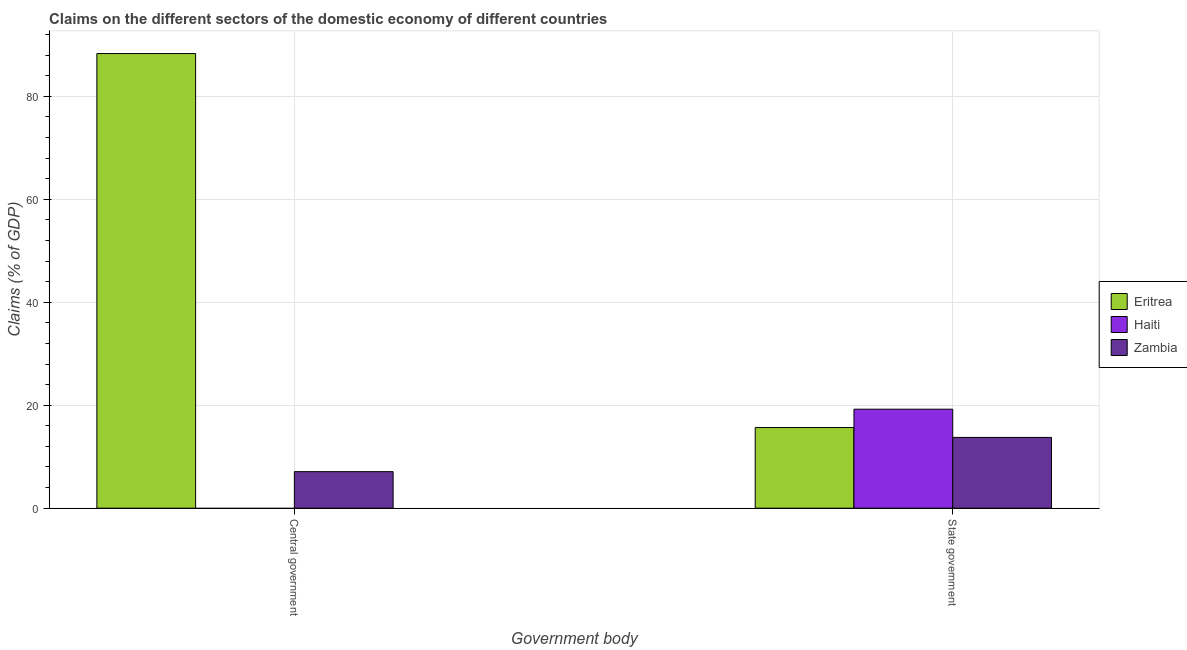Are the number of bars per tick equal to the number of legend labels?
Offer a terse response. No. What is the label of the 1st group of bars from the left?
Make the answer very short. Central government. What is the claims on state government in Zambia?
Ensure brevity in your answer.  13.75. Across all countries, what is the maximum claims on central government?
Keep it short and to the point. 88.29. In which country was the claims on state government maximum?
Offer a terse response. Haiti. What is the total claims on state government in the graph?
Your response must be concise. 48.63. What is the difference between the claims on state government in Eritrea and that in Zambia?
Ensure brevity in your answer.  1.91. What is the difference between the claims on state government in Eritrea and the claims on central government in Zambia?
Keep it short and to the point. 8.56. What is the average claims on state government per country?
Provide a succinct answer. 16.21. What is the difference between the claims on central government and claims on state government in Eritrea?
Your answer should be very brief. 72.63. In how many countries, is the claims on central government greater than 72 %?
Keep it short and to the point. 1. What is the ratio of the claims on state government in Haiti to that in Eritrea?
Your answer should be very brief. 1.23. In how many countries, is the claims on state government greater than the average claims on state government taken over all countries?
Ensure brevity in your answer.  1. How many bars are there?
Give a very brief answer. 5. How many countries are there in the graph?
Give a very brief answer. 3. Does the graph contain any zero values?
Offer a very short reply. Yes. Does the graph contain grids?
Provide a short and direct response. Yes. How many legend labels are there?
Make the answer very short. 3. How are the legend labels stacked?
Provide a succinct answer. Vertical. What is the title of the graph?
Your response must be concise. Claims on the different sectors of the domestic economy of different countries. Does "Sierra Leone" appear as one of the legend labels in the graph?
Ensure brevity in your answer.  No. What is the label or title of the X-axis?
Give a very brief answer. Government body. What is the label or title of the Y-axis?
Make the answer very short. Claims (% of GDP). What is the Claims (% of GDP) in Eritrea in Central government?
Keep it short and to the point. 88.29. What is the Claims (% of GDP) of Zambia in Central government?
Give a very brief answer. 7.1. What is the Claims (% of GDP) of Eritrea in State government?
Your answer should be very brief. 15.66. What is the Claims (% of GDP) in Haiti in State government?
Provide a succinct answer. 19.23. What is the Claims (% of GDP) in Zambia in State government?
Your response must be concise. 13.75. Across all Government body, what is the maximum Claims (% of GDP) in Eritrea?
Ensure brevity in your answer.  88.29. Across all Government body, what is the maximum Claims (% of GDP) of Haiti?
Offer a terse response. 19.23. Across all Government body, what is the maximum Claims (% of GDP) in Zambia?
Offer a very short reply. 13.75. Across all Government body, what is the minimum Claims (% of GDP) of Eritrea?
Provide a succinct answer. 15.66. Across all Government body, what is the minimum Claims (% of GDP) of Haiti?
Make the answer very short. 0. Across all Government body, what is the minimum Claims (% of GDP) in Zambia?
Give a very brief answer. 7.1. What is the total Claims (% of GDP) of Eritrea in the graph?
Give a very brief answer. 103.95. What is the total Claims (% of GDP) of Haiti in the graph?
Your answer should be very brief. 19.23. What is the total Claims (% of GDP) in Zambia in the graph?
Keep it short and to the point. 20.84. What is the difference between the Claims (% of GDP) of Eritrea in Central government and that in State government?
Make the answer very short. 72.63. What is the difference between the Claims (% of GDP) in Zambia in Central government and that in State government?
Provide a short and direct response. -6.65. What is the difference between the Claims (% of GDP) of Eritrea in Central government and the Claims (% of GDP) of Haiti in State government?
Offer a terse response. 69.07. What is the difference between the Claims (% of GDP) of Eritrea in Central government and the Claims (% of GDP) of Zambia in State government?
Ensure brevity in your answer.  74.55. What is the average Claims (% of GDP) in Eritrea per Government body?
Give a very brief answer. 51.98. What is the average Claims (% of GDP) in Haiti per Government body?
Offer a terse response. 9.61. What is the average Claims (% of GDP) of Zambia per Government body?
Provide a succinct answer. 10.42. What is the difference between the Claims (% of GDP) in Eritrea and Claims (% of GDP) in Zambia in Central government?
Offer a terse response. 81.19. What is the difference between the Claims (% of GDP) of Eritrea and Claims (% of GDP) of Haiti in State government?
Your answer should be compact. -3.56. What is the difference between the Claims (% of GDP) in Eritrea and Claims (% of GDP) in Zambia in State government?
Offer a very short reply. 1.91. What is the difference between the Claims (% of GDP) in Haiti and Claims (% of GDP) in Zambia in State government?
Your answer should be compact. 5.48. What is the ratio of the Claims (% of GDP) in Eritrea in Central government to that in State government?
Your response must be concise. 5.64. What is the ratio of the Claims (% of GDP) in Zambia in Central government to that in State government?
Offer a terse response. 0.52. What is the difference between the highest and the second highest Claims (% of GDP) in Eritrea?
Give a very brief answer. 72.63. What is the difference between the highest and the second highest Claims (% of GDP) in Zambia?
Your answer should be very brief. 6.65. What is the difference between the highest and the lowest Claims (% of GDP) in Eritrea?
Provide a short and direct response. 72.63. What is the difference between the highest and the lowest Claims (% of GDP) of Haiti?
Offer a terse response. 19.23. What is the difference between the highest and the lowest Claims (% of GDP) in Zambia?
Your response must be concise. 6.65. 